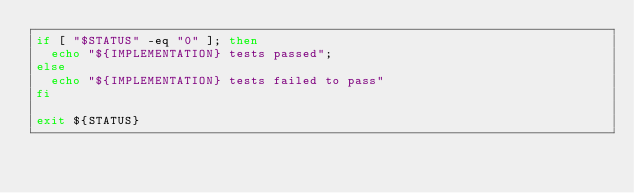Convert code to text. <code><loc_0><loc_0><loc_500><loc_500><_Bash_>if [ "$STATUS" -eq "0" ]; then
	echo "${IMPLEMENTATION} tests passed";
else
	echo "${IMPLEMENTATION} tests failed to pass"
fi

exit ${STATUS}
</code> 